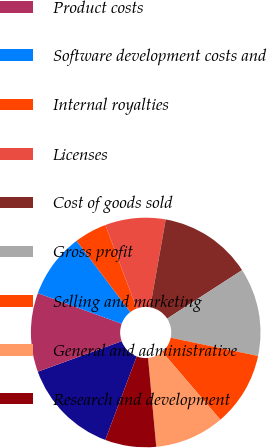Convert chart to OTSL. <chart><loc_0><loc_0><loc_500><loc_500><pie_chart><fcel>Net revenue<fcel>Product costs<fcel>Software development costs and<fcel>Internal royalties<fcel>Licenses<fcel>Cost of goods sold<fcel>Gross profit<fcel>Selling and marketing<fcel>General and administrative<fcel>Research and development<nl><fcel>13.73%<fcel>11.11%<fcel>9.15%<fcel>4.58%<fcel>8.5%<fcel>13.07%<fcel>12.42%<fcel>10.46%<fcel>9.8%<fcel>7.19%<nl></chart> 